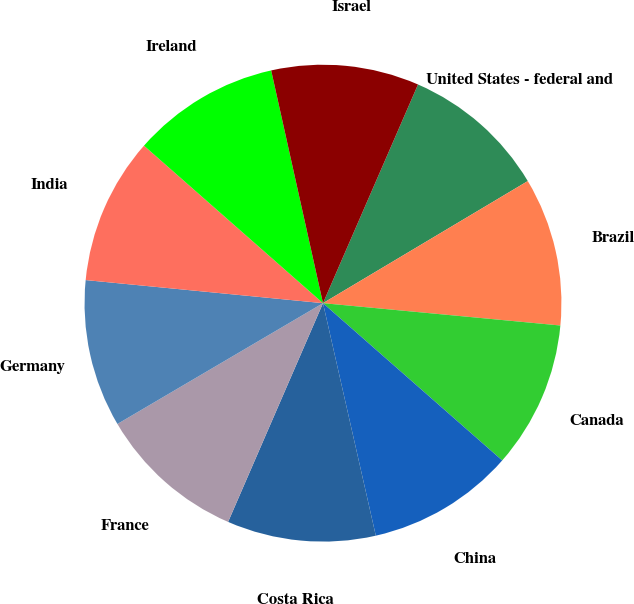<chart> <loc_0><loc_0><loc_500><loc_500><pie_chart><fcel>United States - federal and<fcel>Brazil<fcel>Canada<fcel>China<fcel>Costa Rica<fcel>France<fcel>Germany<fcel>India<fcel>Ireland<fcel>Israel<nl><fcel>9.92%<fcel>10.05%<fcel>9.97%<fcel>9.98%<fcel>10.07%<fcel>10.03%<fcel>10.0%<fcel>9.94%<fcel>10.03%<fcel>10.01%<nl></chart> 